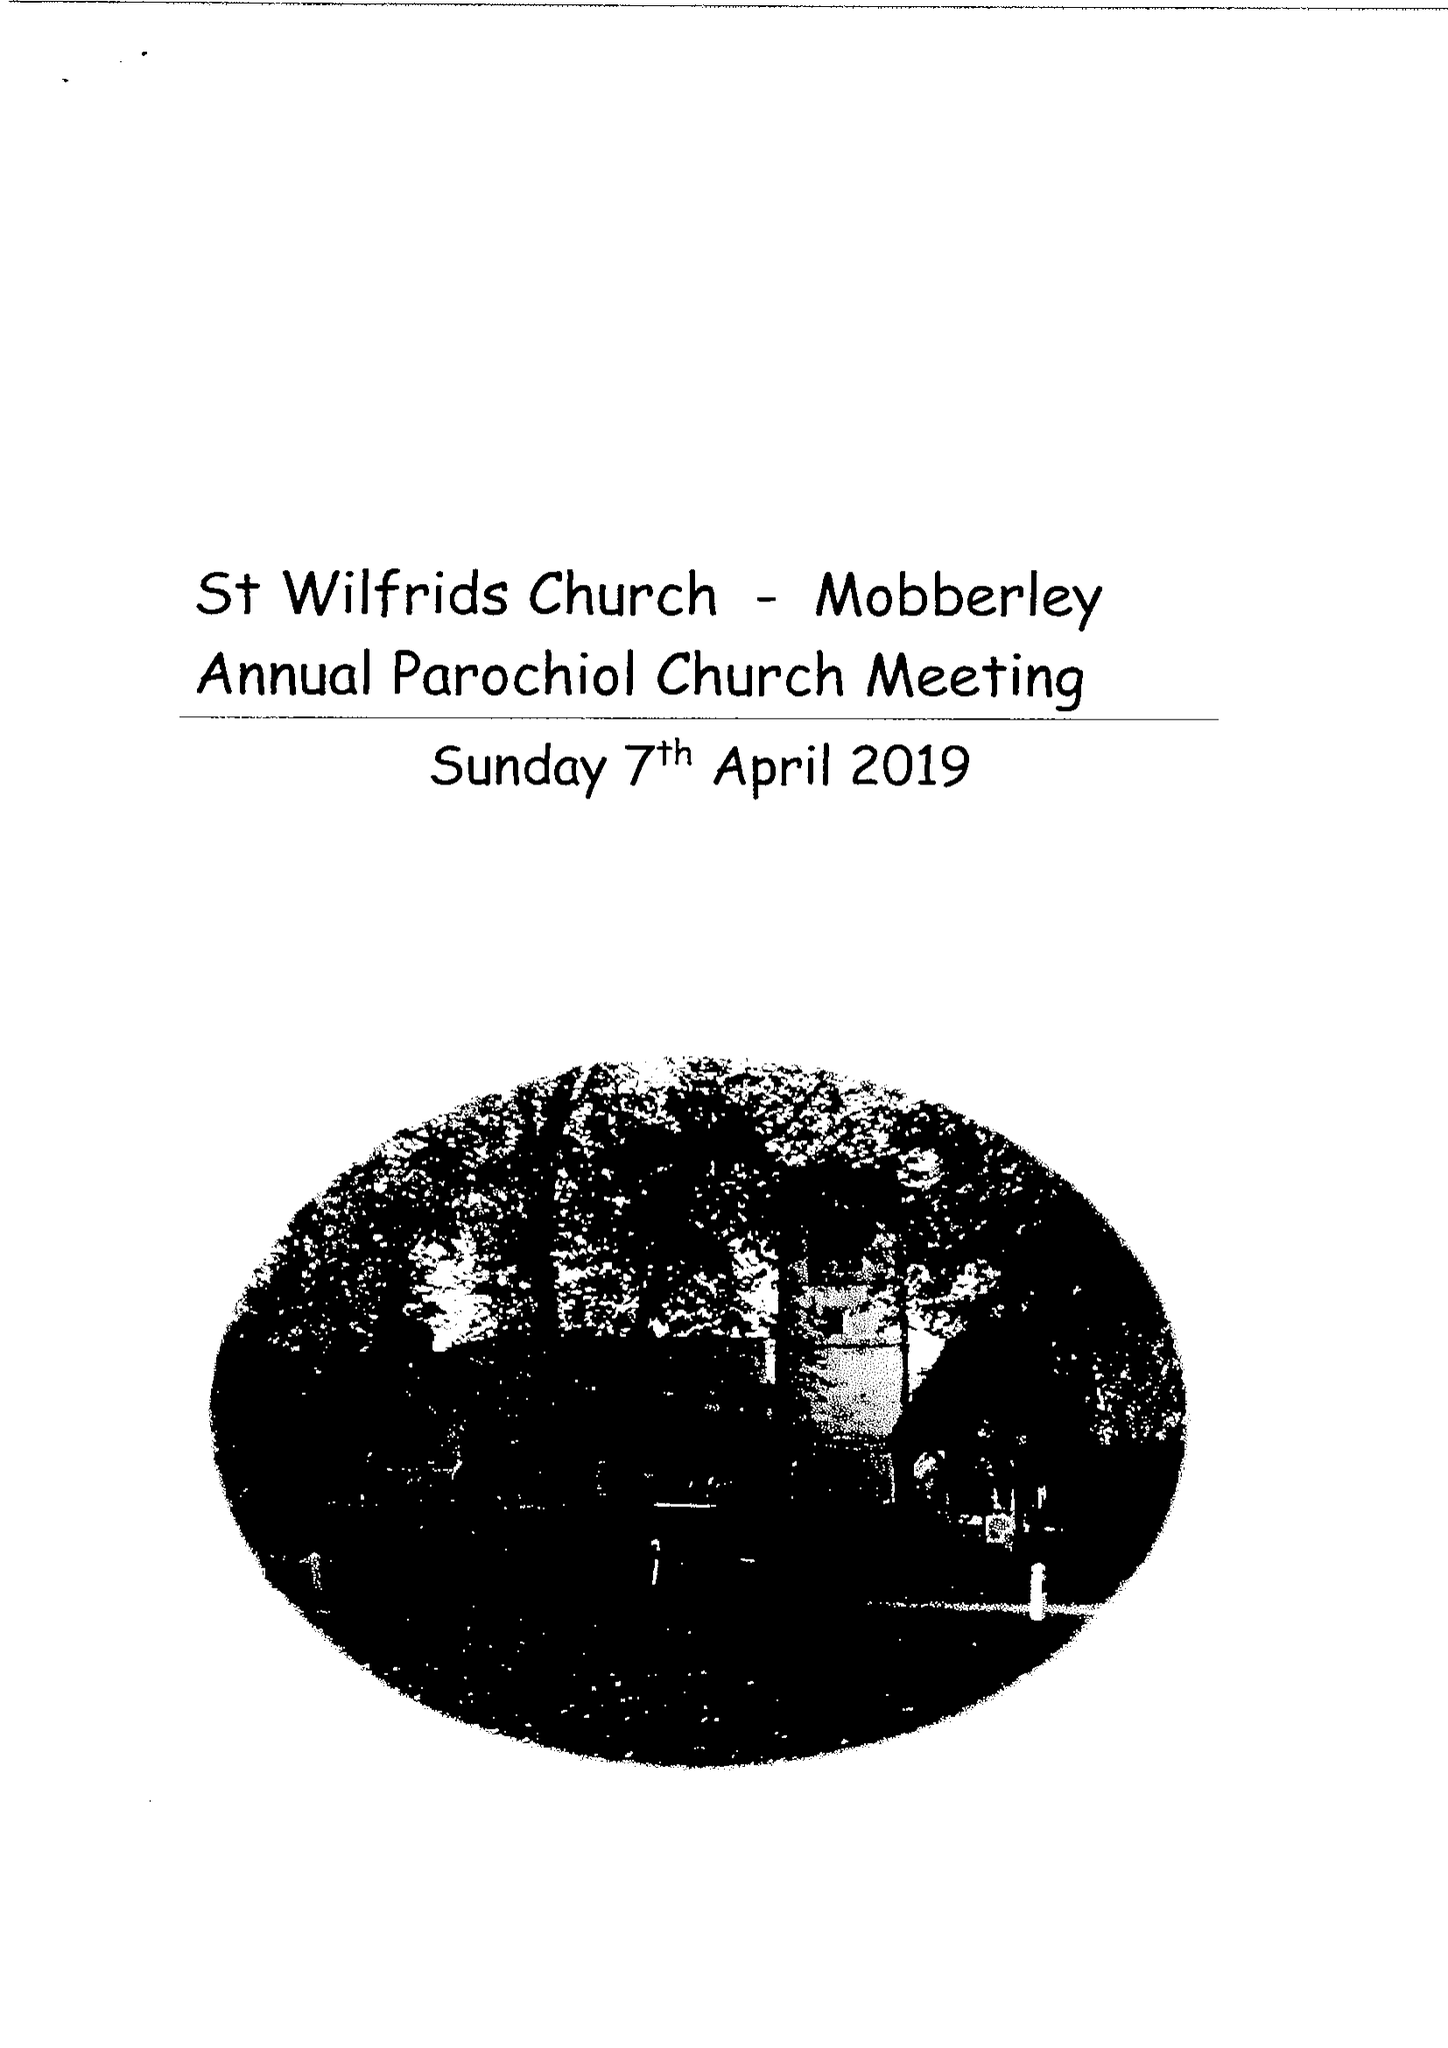What is the value for the address__post_town?
Answer the question using a single word or phrase. KNUTSFORD 